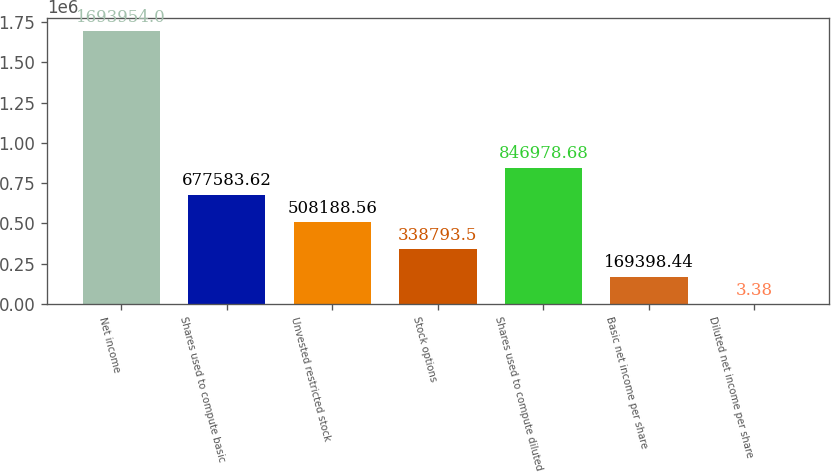Convert chart to OTSL. <chart><loc_0><loc_0><loc_500><loc_500><bar_chart><fcel>Net income<fcel>Shares used to compute basic<fcel>Unvested restricted stock<fcel>Stock options<fcel>Shares used to compute diluted<fcel>Basic net income per share<fcel>Diluted net income per share<nl><fcel>1.69395e+06<fcel>677584<fcel>508189<fcel>338794<fcel>846979<fcel>169398<fcel>3.38<nl></chart> 